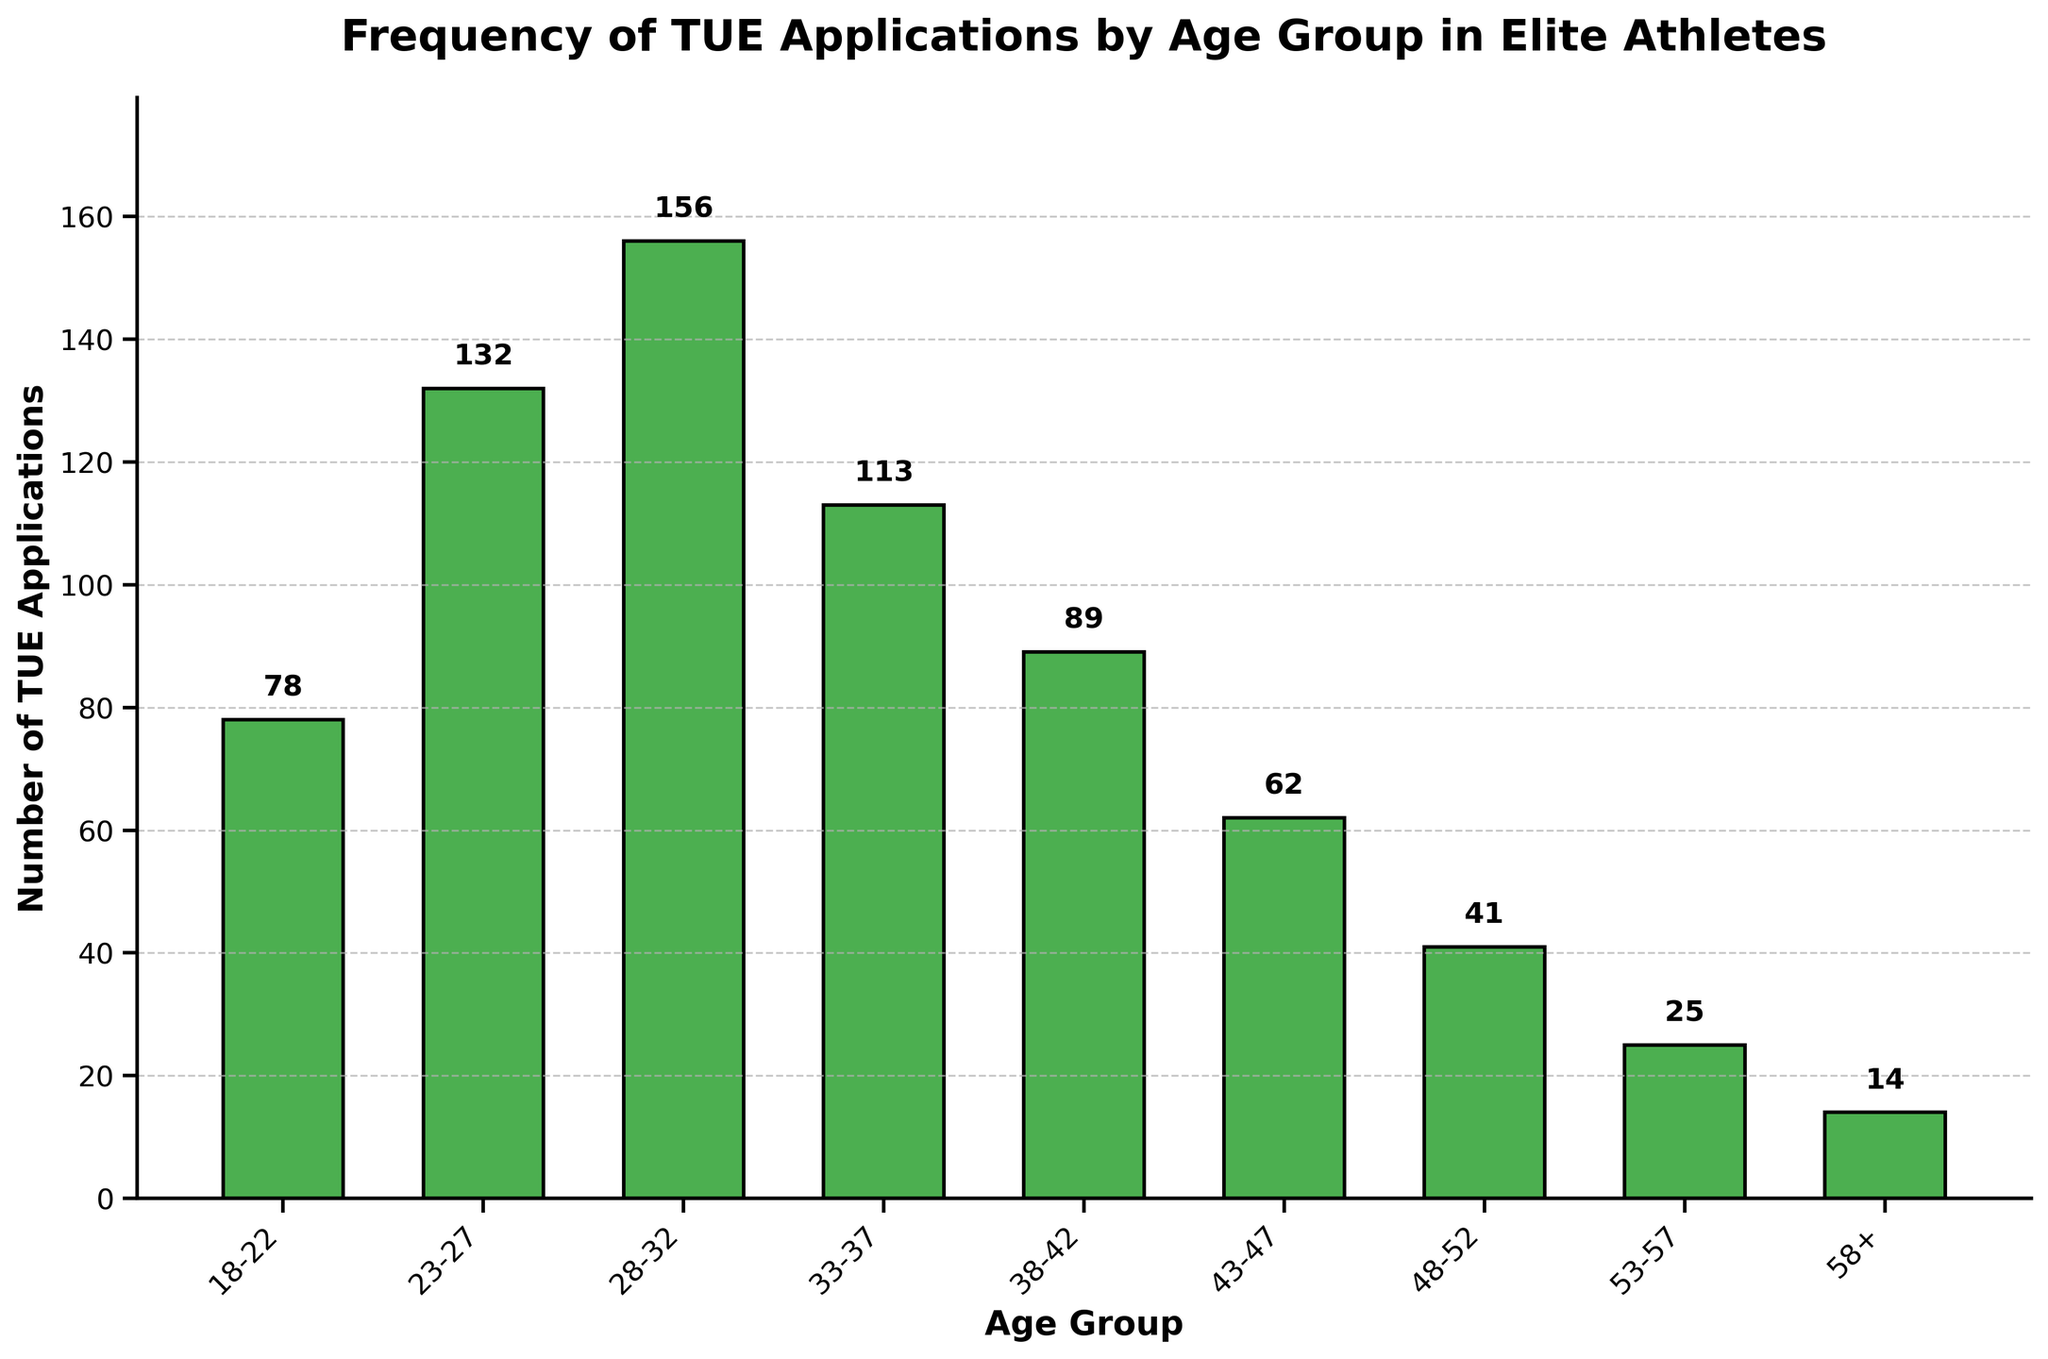What age group has the highest number of TUE applications? The bar representing the 28-32 age group is the tallest, indicating it has the highest number of TUE applications.
Answer: 28-32 Which age group has the lowest number of TUE applications? The bar representing the 58+ age group is the shortest, indicating it has the lowest number of TUE applications.
Answer: 58+ What is the total number of TUE applications for athletes under 30? Add the number of TUE applications for the 18-22 and 23-27 age groups: 78 + 132 = 210.
Answer: 210 Compare the TUE applications between the 28-32 and 33-37 age groups. Which one has more, and by how much? The 28-32 age group has 156 applications, and the 33-37 age group has 113 applications. The difference is 156 - 113 = 43.
Answer: 28-32 by 43 How many more TUE applications do athletes aged 33-37 have compared to those aged 38-42? The 33-37 age group has 113 applications, and the 38-42 age group has 89 applications. The difference is 113 - 89 = 24.
Answer: 24 What is the average number of TUE applications per age group? Sum the total TUE applications and divide by the number of age groups: (78 + 132 + 156 + 113 + 89 + 62 + 41 + 25 + 14) / 9 = 710 / 9 ≈ 78.89 (rounded to two decimal places).
Answer: 78.89 Compare the number of TUE applications between athletes aged 23-27 and 43-47. How many more applications are there in the 23-27 age group? The 23-27 age group has 132 applications, and the 43-47 age group has 62 applications. The difference is 132 - 62 = 70.
Answer: 70 Which two age groups have the closest number of TUE applications, and what is the difference between them? The 33-37 age group has 113 applications, and the 38-42 age group has 89 applications. The difference is 113 - 89 = 24.
Answer: 33-37 and 38-42, by 24 